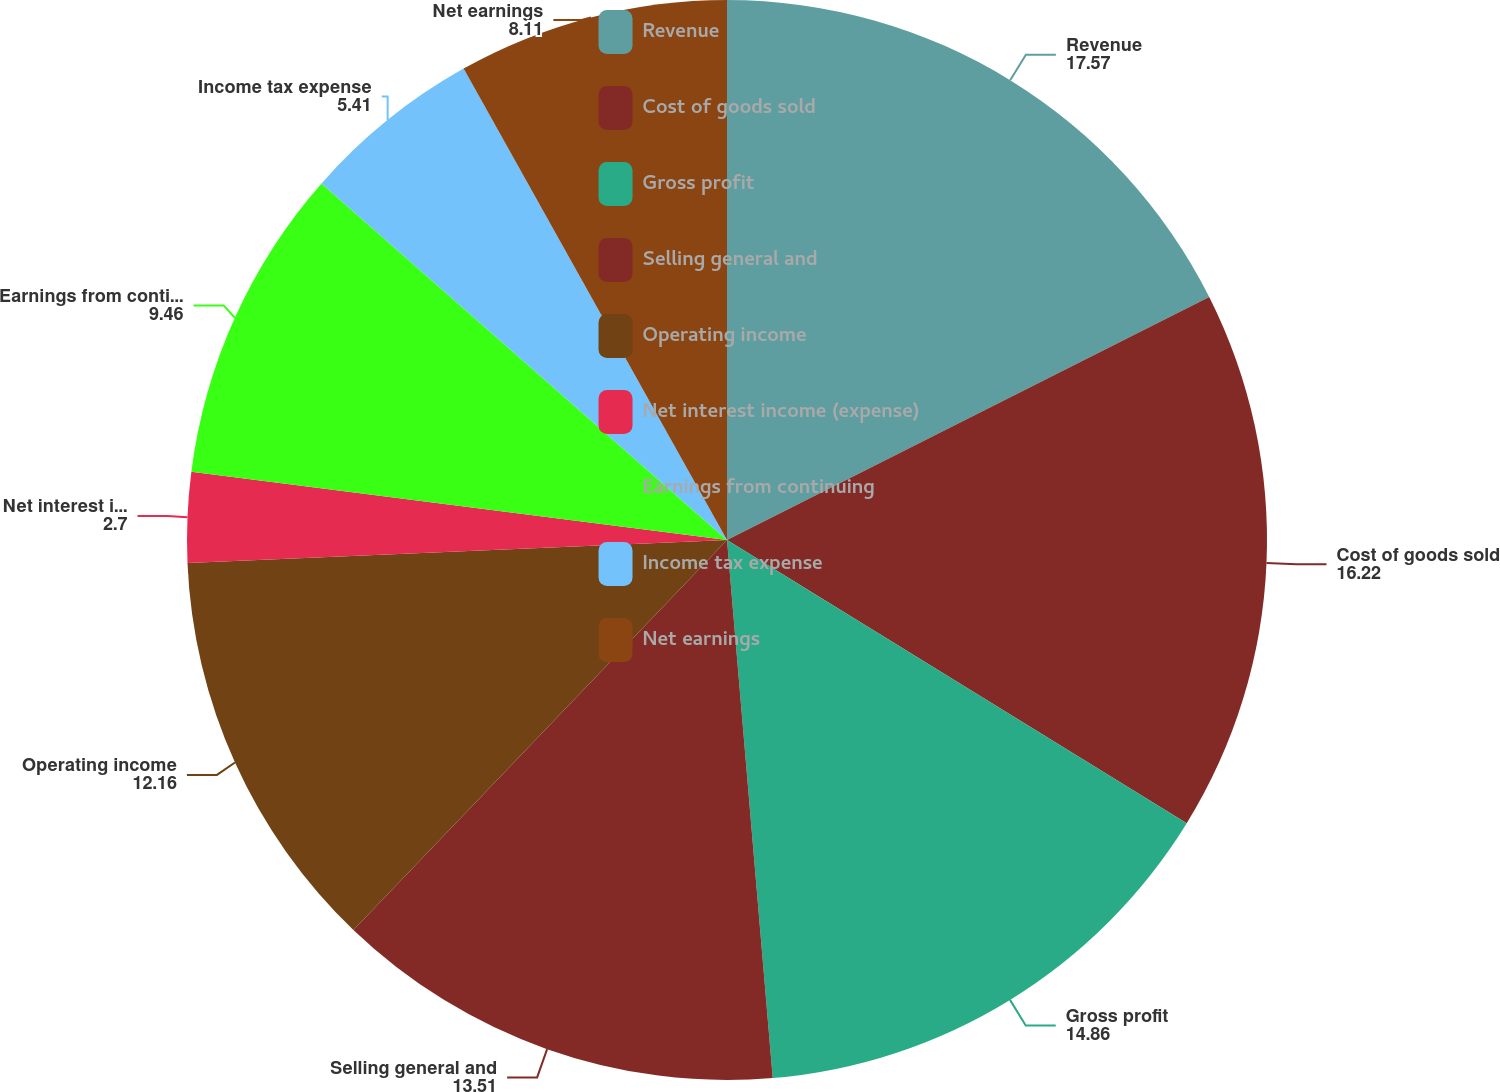Convert chart. <chart><loc_0><loc_0><loc_500><loc_500><pie_chart><fcel>Revenue<fcel>Cost of goods sold<fcel>Gross profit<fcel>Selling general and<fcel>Operating income<fcel>Net interest income (expense)<fcel>Earnings from continuing<fcel>Income tax expense<fcel>Net earnings<nl><fcel>17.57%<fcel>16.22%<fcel>14.86%<fcel>13.51%<fcel>12.16%<fcel>2.7%<fcel>9.46%<fcel>5.41%<fcel>8.11%<nl></chart> 